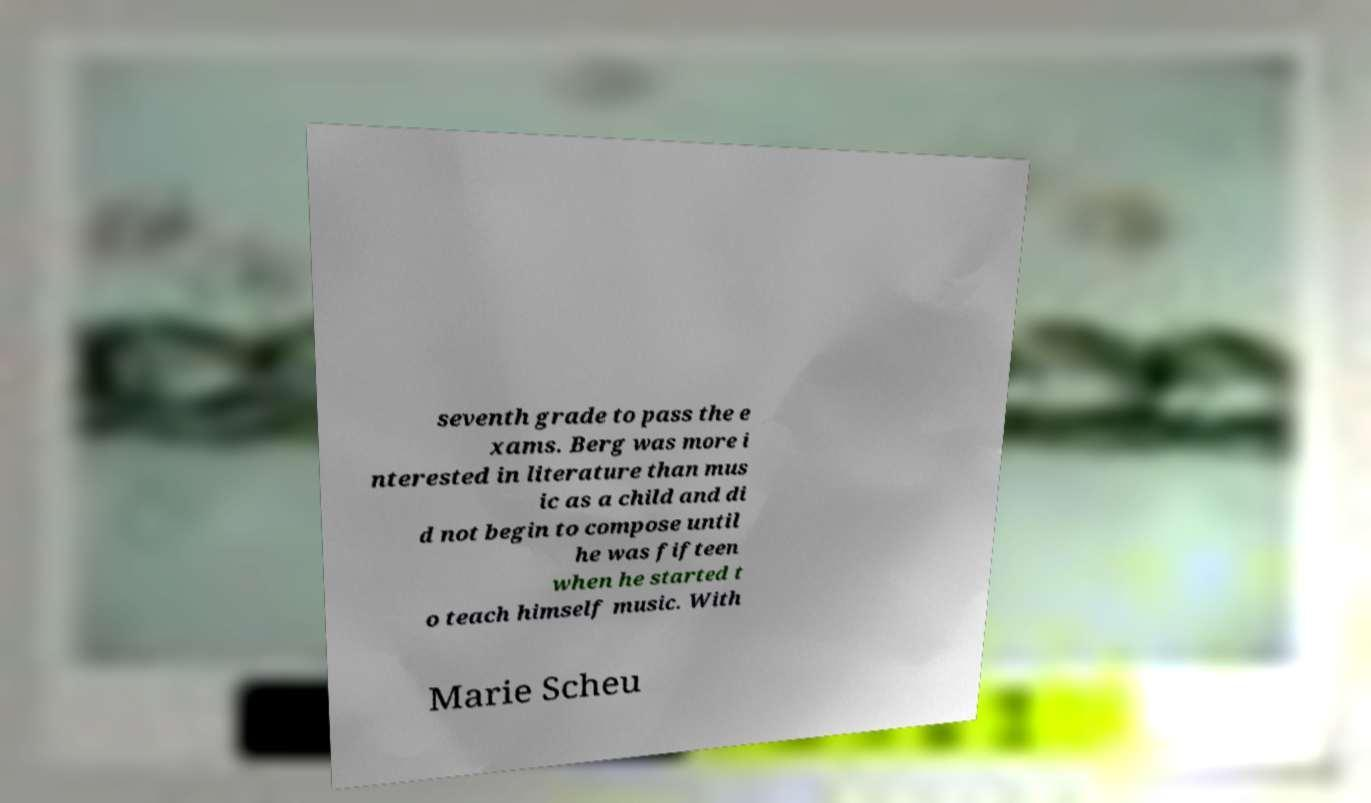Could you extract and type out the text from this image? seventh grade to pass the e xams. Berg was more i nterested in literature than mus ic as a child and di d not begin to compose until he was fifteen when he started t o teach himself music. With Marie Scheu 